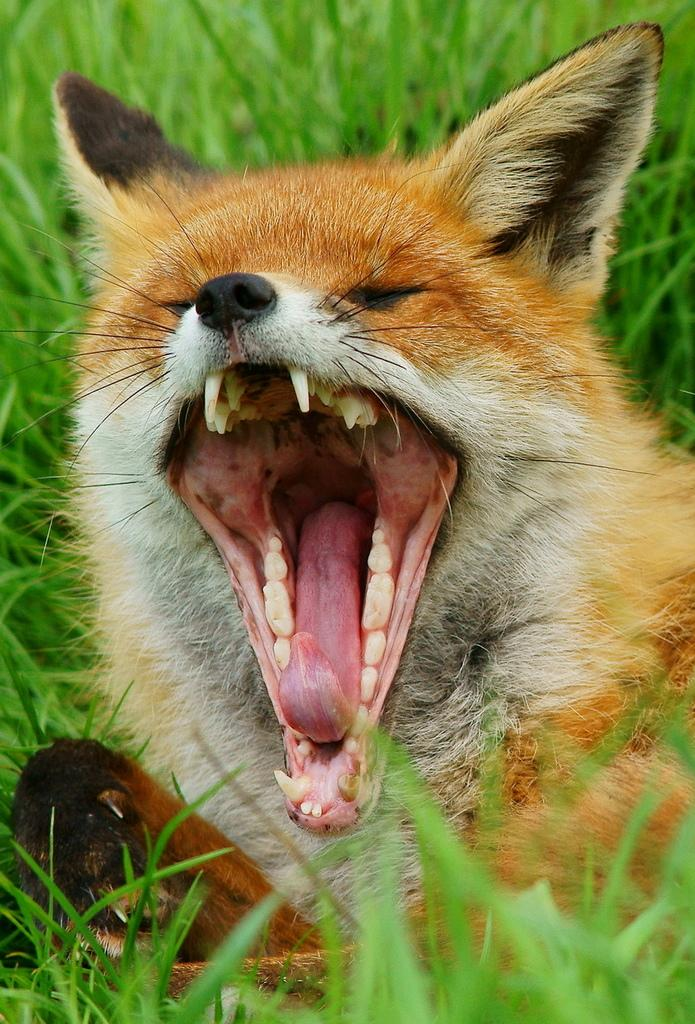What type of animal is in the image? There is a red fox in the image. What is the red fox doing in the image? The red fox is yawning. Where is the red fox located in the image? The red fox is on the grass. What type of activity is the red fox participating in during the battle in the image? There is no battle present in the image, and the red fox is not participating in any activity. Can you describe the red fox's swimming technique in the image? There is no swimming activity depicted in the image, as the red fox is on the grass and not in water. 